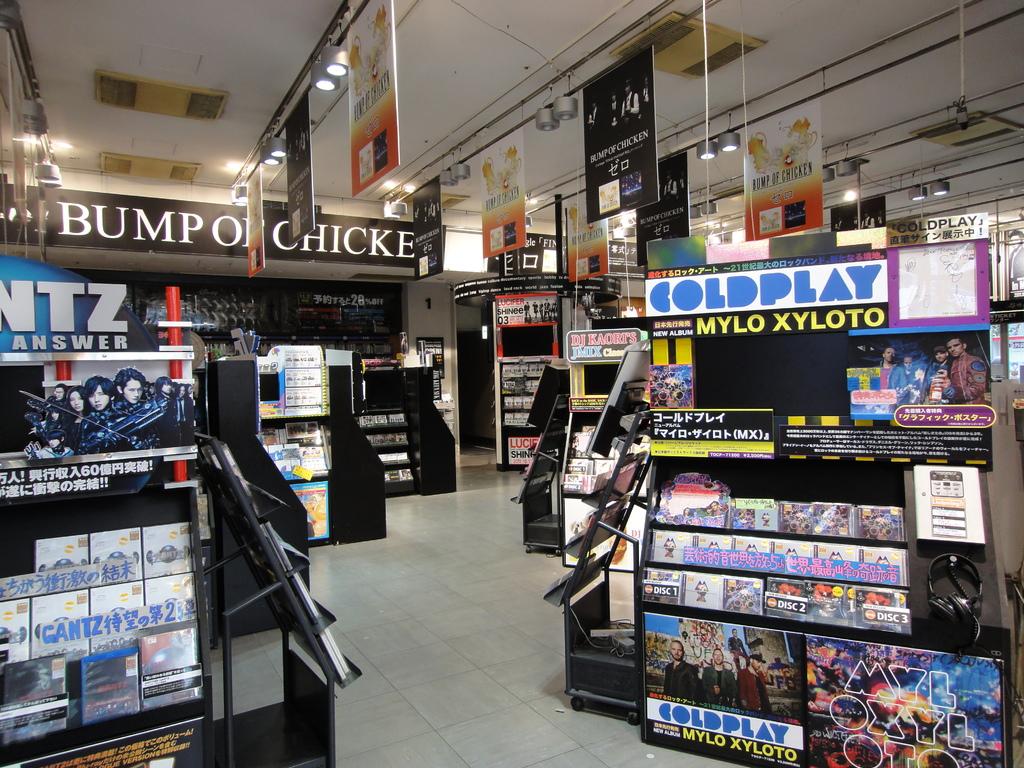What is the name of the store?
Provide a succinct answer. Bump of chicken. What band is named on the display on the right?
Your answer should be compact. Coldplay. 